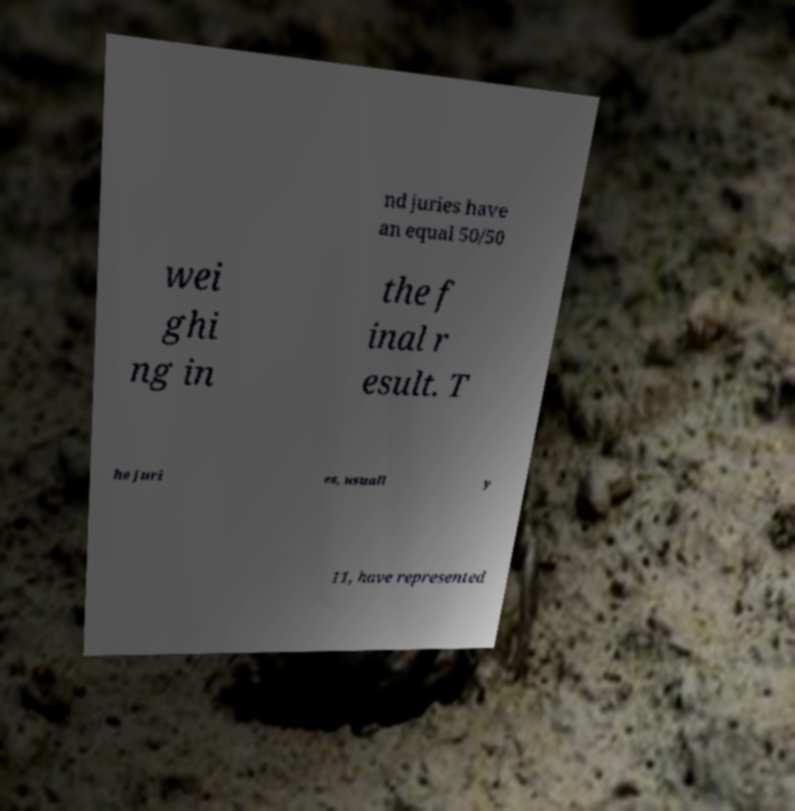Please read and relay the text visible in this image. What does it say? nd juries have an equal 50/50 wei ghi ng in the f inal r esult. T he juri es, usuall y 11, have represented 